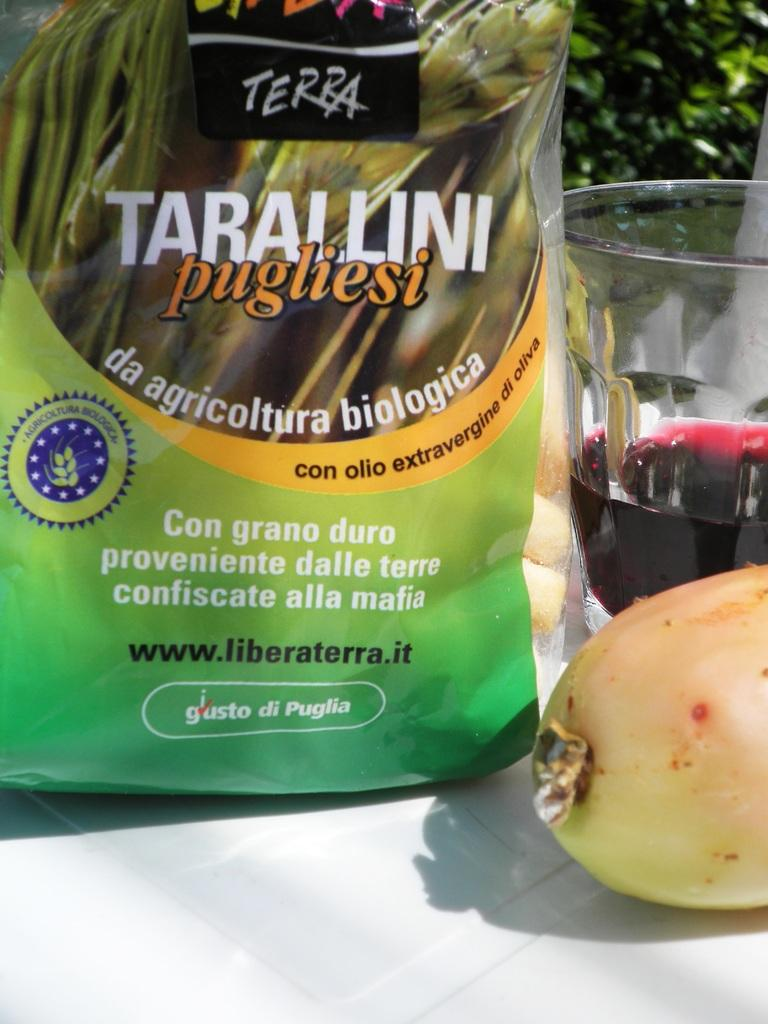<image>
Offer a succinct explanation of the picture presented. A green bag has Terra and Tarallini on the front. 